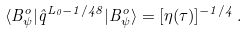Convert formula to latex. <formula><loc_0><loc_0><loc_500><loc_500>\langle B ^ { o } _ { \psi } | \hat { q } ^ { L _ { 0 } - 1 / 4 8 } | B ^ { o } _ { \psi } \rangle = [ \eta ( \tau ) ] ^ { - 1 / 4 } \, .</formula> 